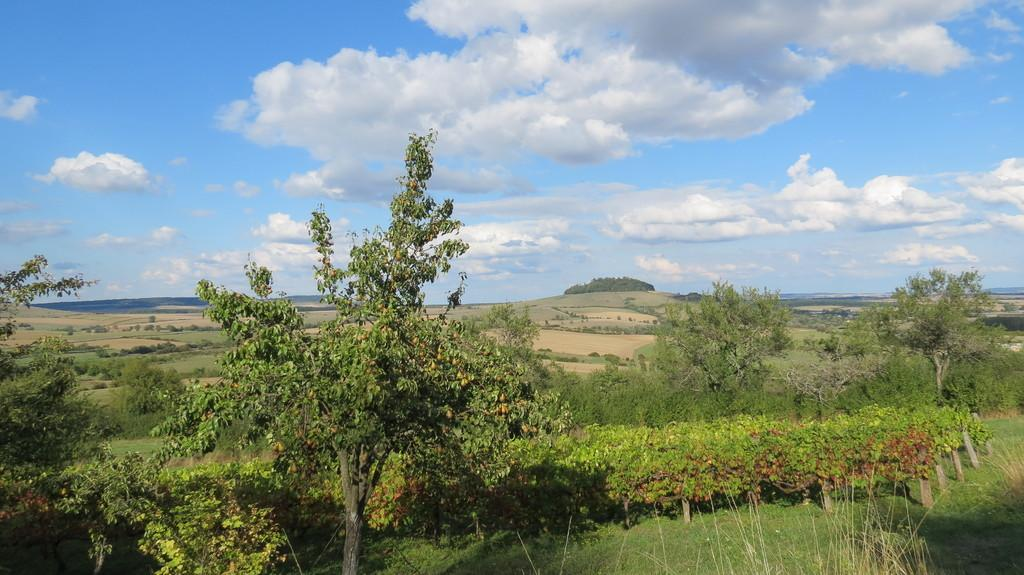What type of vegetation is in the foreground of the image? There is grass, plants, and trees in the foreground of the image. What can be seen in the background of the image? The sky is visible at the top of the image. What type of environment might the image depict? The image may have been taken in a forest, given the presence of trees and other vegetation. What type of attraction can be seen in the image? There is no attraction present in the image; it depicts natural elements such as grass, plants, trees, and the sky. Can you tell me how many people are swimming in the image? There is no swimming or people visible in the image; it features natural elements and the sky. 